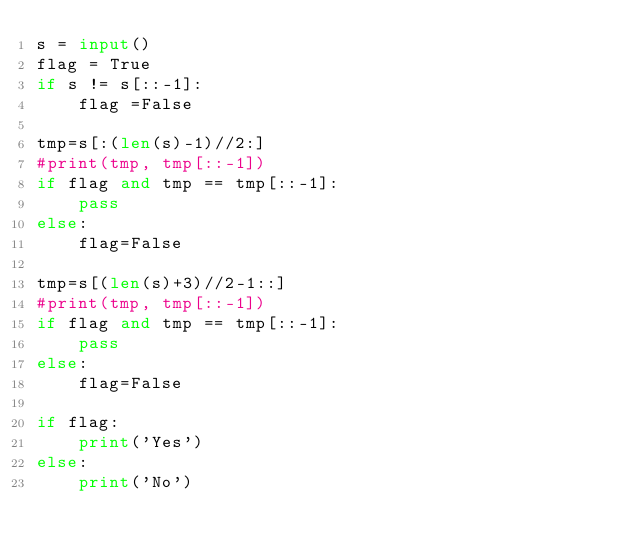<code> <loc_0><loc_0><loc_500><loc_500><_Python_>s = input()
flag = True
if s != s[::-1]:
    flag =False

tmp=s[:(len(s)-1)//2:]
#print(tmp, tmp[::-1])
if flag and tmp == tmp[::-1]:
    pass
else:
    flag=False

tmp=s[(len(s)+3)//2-1::]
#print(tmp, tmp[::-1])
if flag and tmp == tmp[::-1]:
    pass
else:
    flag=False

if flag:
    print('Yes')
else:
    print('No')
</code> 